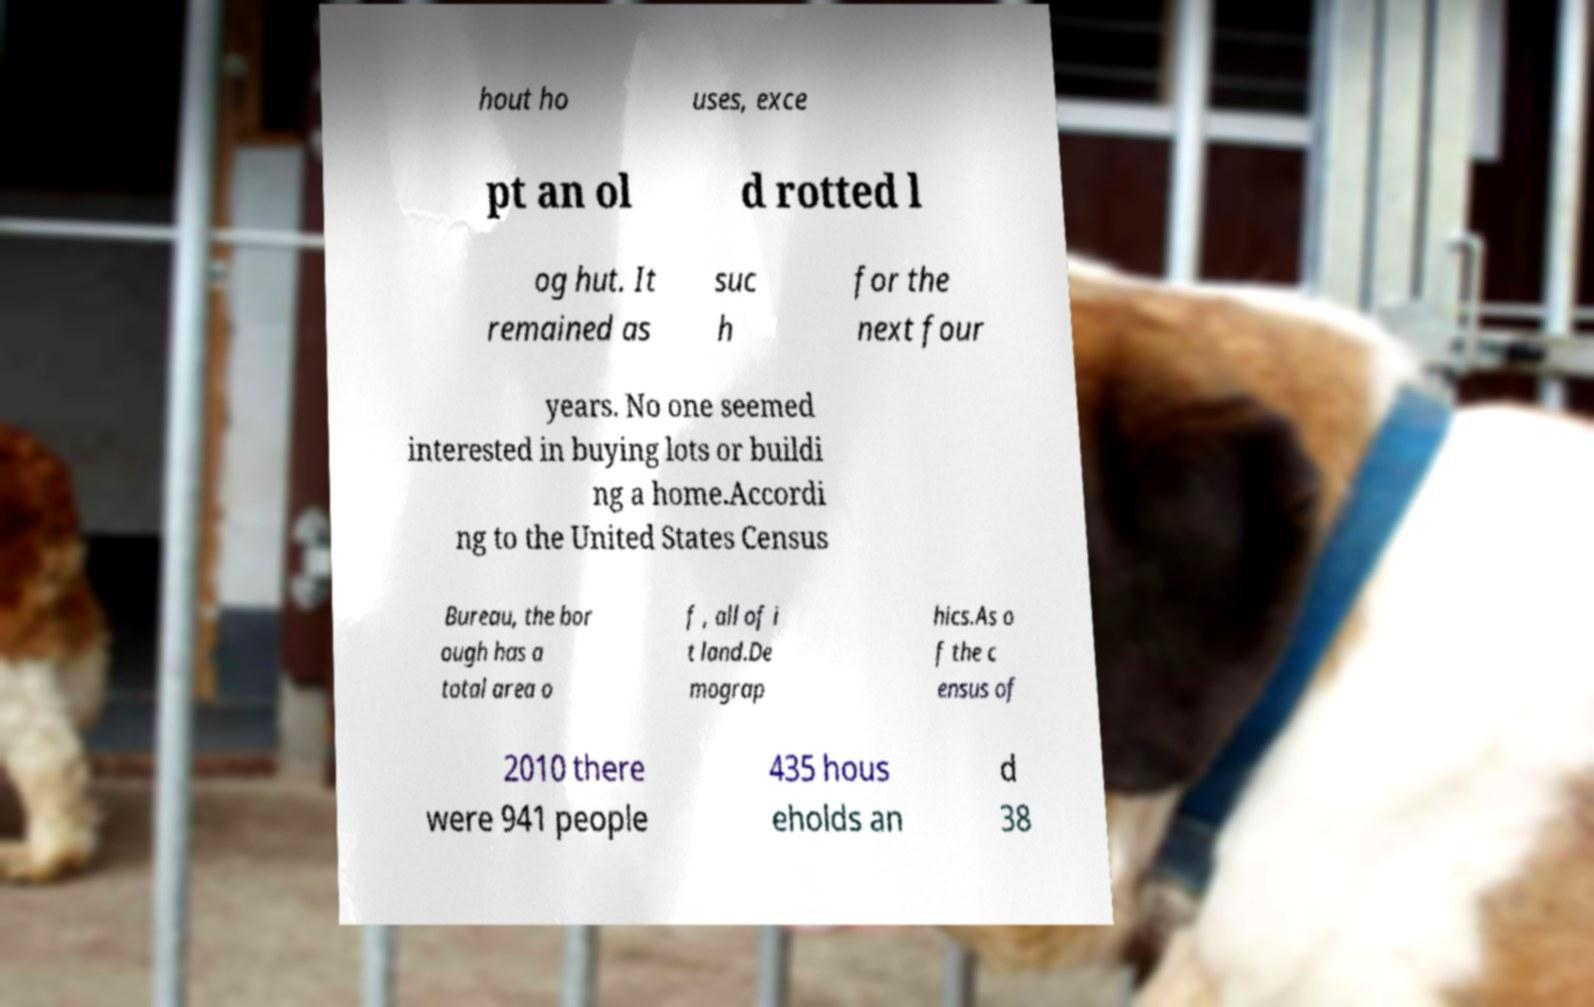Could you assist in decoding the text presented in this image and type it out clearly? hout ho uses, exce pt an ol d rotted l og hut. It remained as suc h for the next four years. No one seemed interested in buying lots or buildi ng a home.Accordi ng to the United States Census Bureau, the bor ough has a total area o f , all of i t land.De mograp hics.As o f the c ensus of 2010 there were 941 people 435 hous eholds an d 38 